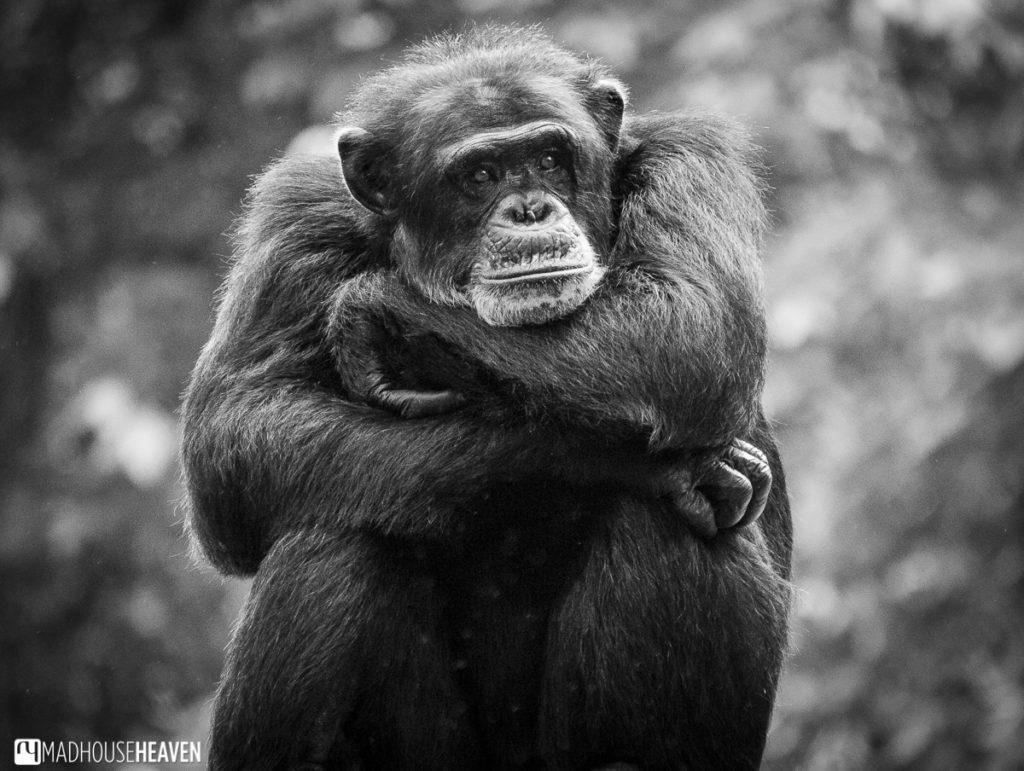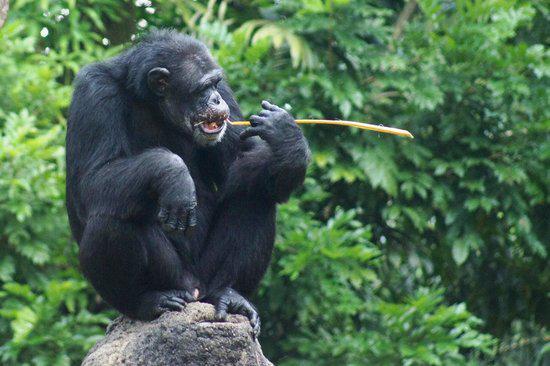The first image is the image on the left, the second image is the image on the right. For the images shown, is this caption "a child ape is on its mothers back." true? Answer yes or no. No. The first image is the image on the left, the second image is the image on the right. Analyze the images presented: Is the assertion "A baby ape is riding it's mothers back." valid? Answer yes or no. No. The first image is the image on the left, the second image is the image on the right. Given the left and right images, does the statement "One of the images shows one monkey riding on the back of another monkey." hold true? Answer yes or no. No. 